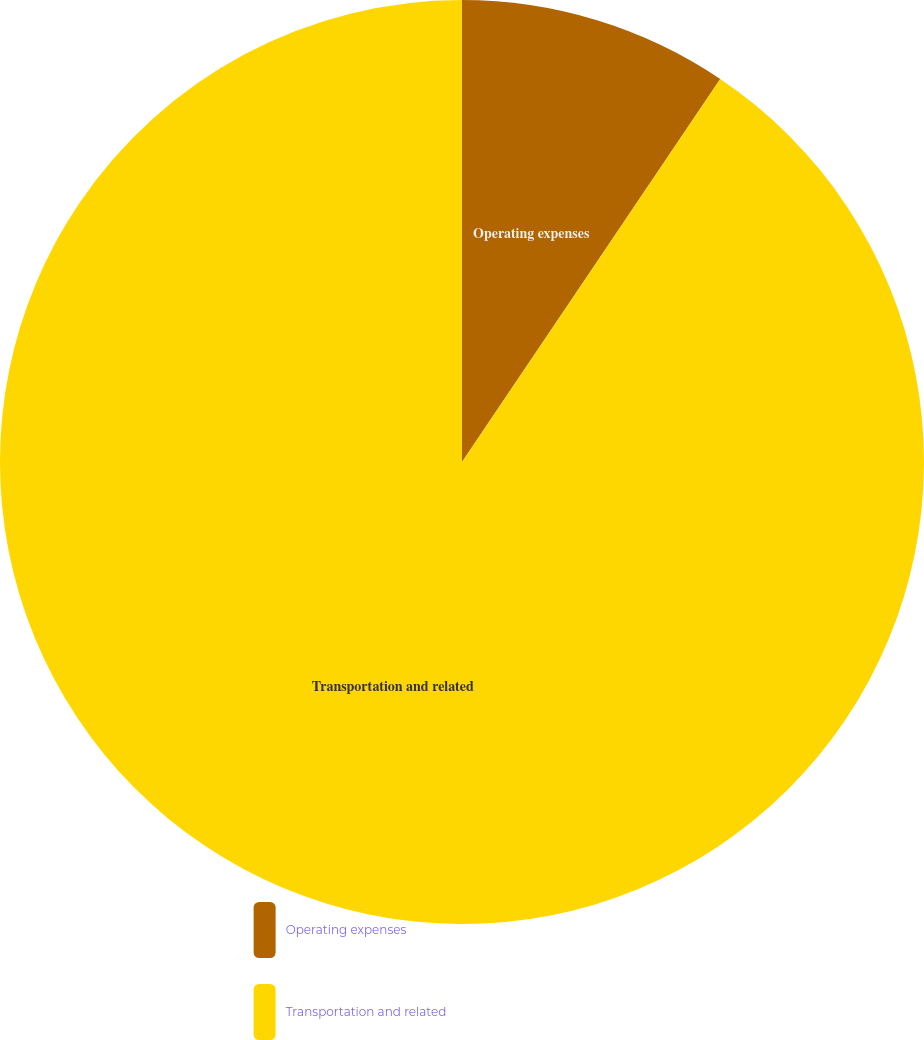Convert chart. <chart><loc_0><loc_0><loc_500><loc_500><pie_chart><fcel>Operating expenses<fcel>Transportation and related<nl><fcel>9.44%<fcel>90.56%<nl></chart> 